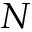Convert formula to latex. <formula><loc_0><loc_0><loc_500><loc_500>N</formula> 